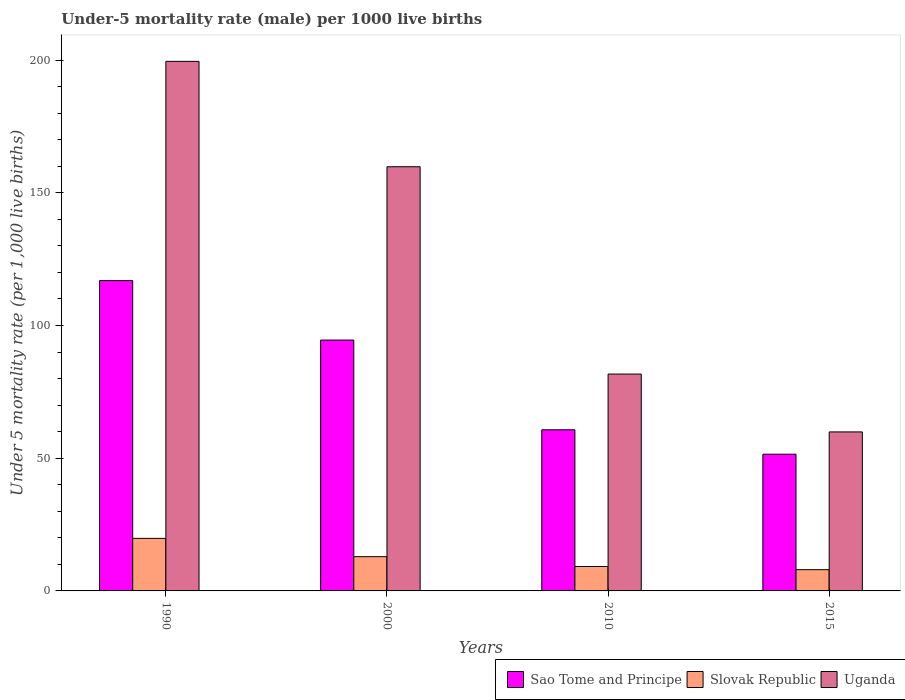How many different coloured bars are there?
Keep it short and to the point. 3. How many groups of bars are there?
Offer a very short reply. 4. Are the number of bars on each tick of the X-axis equal?
Your response must be concise. Yes. How many bars are there on the 1st tick from the right?
Provide a short and direct response. 3. What is the label of the 4th group of bars from the left?
Offer a very short reply. 2015. In how many cases, is the number of bars for a given year not equal to the number of legend labels?
Your answer should be compact. 0. Across all years, what is the maximum under-five mortality rate in Slovak Republic?
Your answer should be compact. 19.8. Across all years, what is the minimum under-five mortality rate in Sao Tome and Principe?
Your response must be concise. 51.5. In which year was the under-five mortality rate in Slovak Republic maximum?
Ensure brevity in your answer.  1990. In which year was the under-five mortality rate in Uganda minimum?
Offer a very short reply. 2015. What is the total under-five mortality rate in Uganda in the graph?
Provide a succinct answer. 500.9. What is the difference between the under-five mortality rate in Sao Tome and Principe in 2010 and that in 2015?
Your answer should be very brief. 9.2. What is the difference between the under-five mortality rate in Slovak Republic in 2010 and the under-five mortality rate in Uganda in 2015?
Make the answer very short. -50.7. What is the average under-five mortality rate in Slovak Republic per year?
Offer a terse response. 12.48. In the year 1990, what is the difference between the under-five mortality rate in Sao Tome and Principe and under-five mortality rate in Uganda?
Your response must be concise. -82.6. What is the ratio of the under-five mortality rate in Slovak Republic in 1990 to that in 2000?
Your answer should be compact. 1.53. What is the difference between the highest and the second highest under-five mortality rate in Sao Tome and Principe?
Give a very brief answer. 22.4. What is the difference between the highest and the lowest under-five mortality rate in Slovak Republic?
Your answer should be compact. 11.8. In how many years, is the under-five mortality rate in Slovak Republic greater than the average under-five mortality rate in Slovak Republic taken over all years?
Make the answer very short. 2. Is the sum of the under-five mortality rate in Uganda in 1990 and 2015 greater than the maximum under-five mortality rate in Sao Tome and Principe across all years?
Keep it short and to the point. Yes. What does the 1st bar from the left in 2010 represents?
Your response must be concise. Sao Tome and Principe. What does the 2nd bar from the right in 2015 represents?
Offer a very short reply. Slovak Republic. Is it the case that in every year, the sum of the under-five mortality rate in Uganda and under-five mortality rate in Sao Tome and Principe is greater than the under-five mortality rate in Slovak Republic?
Your response must be concise. Yes. How many bars are there?
Your answer should be compact. 12. Are all the bars in the graph horizontal?
Offer a very short reply. No. How many years are there in the graph?
Your response must be concise. 4. Does the graph contain grids?
Offer a terse response. No. Where does the legend appear in the graph?
Offer a very short reply. Bottom right. How are the legend labels stacked?
Provide a short and direct response. Horizontal. What is the title of the graph?
Give a very brief answer. Under-5 mortality rate (male) per 1000 live births. What is the label or title of the X-axis?
Offer a terse response. Years. What is the label or title of the Y-axis?
Make the answer very short. Under 5 mortality rate (per 1,0 live births). What is the Under 5 mortality rate (per 1,000 live births) in Sao Tome and Principe in 1990?
Keep it short and to the point. 116.9. What is the Under 5 mortality rate (per 1,000 live births) in Slovak Republic in 1990?
Keep it short and to the point. 19.8. What is the Under 5 mortality rate (per 1,000 live births) of Uganda in 1990?
Offer a very short reply. 199.5. What is the Under 5 mortality rate (per 1,000 live births) in Sao Tome and Principe in 2000?
Your answer should be compact. 94.5. What is the Under 5 mortality rate (per 1,000 live births) in Uganda in 2000?
Offer a very short reply. 159.8. What is the Under 5 mortality rate (per 1,000 live births) of Sao Tome and Principe in 2010?
Offer a very short reply. 60.7. What is the Under 5 mortality rate (per 1,000 live births) of Slovak Republic in 2010?
Make the answer very short. 9.2. What is the Under 5 mortality rate (per 1,000 live births) in Uganda in 2010?
Offer a terse response. 81.7. What is the Under 5 mortality rate (per 1,000 live births) in Sao Tome and Principe in 2015?
Make the answer very short. 51.5. What is the Under 5 mortality rate (per 1,000 live births) in Slovak Republic in 2015?
Ensure brevity in your answer.  8. What is the Under 5 mortality rate (per 1,000 live births) of Uganda in 2015?
Offer a very short reply. 59.9. Across all years, what is the maximum Under 5 mortality rate (per 1,000 live births) of Sao Tome and Principe?
Give a very brief answer. 116.9. Across all years, what is the maximum Under 5 mortality rate (per 1,000 live births) of Slovak Republic?
Give a very brief answer. 19.8. Across all years, what is the maximum Under 5 mortality rate (per 1,000 live births) in Uganda?
Keep it short and to the point. 199.5. Across all years, what is the minimum Under 5 mortality rate (per 1,000 live births) in Sao Tome and Principe?
Your response must be concise. 51.5. Across all years, what is the minimum Under 5 mortality rate (per 1,000 live births) in Slovak Republic?
Offer a terse response. 8. Across all years, what is the minimum Under 5 mortality rate (per 1,000 live births) of Uganda?
Offer a very short reply. 59.9. What is the total Under 5 mortality rate (per 1,000 live births) of Sao Tome and Principe in the graph?
Keep it short and to the point. 323.6. What is the total Under 5 mortality rate (per 1,000 live births) in Slovak Republic in the graph?
Keep it short and to the point. 49.9. What is the total Under 5 mortality rate (per 1,000 live births) of Uganda in the graph?
Your answer should be very brief. 500.9. What is the difference between the Under 5 mortality rate (per 1,000 live births) of Sao Tome and Principe in 1990 and that in 2000?
Your answer should be very brief. 22.4. What is the difference between the Under 5 mortality rate (per 1,000 live births) in Uganda in 1990 and that in 2000?
Keep it short and to the point. 39.7. What is the difference between the Under 5 mortality rate (per 1,000 live births) in Sao Tome and Principe in 1990 and that in 2010?
Give a very brief answer. 56.2. What is the difference between the Under 5 mortality rate (per 1,000 live births) in Slovak Republic in 1990 and that in 2010?
Give a very brief answer. 10.6. What is the difference between the Under 5 mortality rate (per 1,000 live births) of Uganda in 1990 and that in 2010?
Offer a very short reply. 117.8. What is the difference between the Under 5 mortality rate (per 1,000 live births) of Sao Tome and Principe in 1990 and that in 2015?
Keep it short and to the point. 65.4. What is the difference between the Under 5 mortality rate (per 1,000 live births) of Uganda in 1990 and that in 2015?
Give a very brief answer. 139.6. What is the difference between the Under 5 mortality rate (per 1,000 live births) of Sao Tome and Principe in 2000 and that in 2010?
Ensure brevity in your answer.  33.8. What is the difference between the Under 5 mortality rate (per 1,000 live births) of Slovak Republic in 2000 and that in 2010?
Offer a very short reply. 3.7. What is the difference between the Under 5 mortality rate (per 1,000 live births) in Uganda in 2000 and that in 2010?
Offer a very short reply. 78.1. What is the difference between the Under 5 mortality rate (per 1,000 live births) of Slovak Republic in 2000 and that in 2015?
Your response must be concise. 4.9. What is the difference between the Under 5 mortality rate (per 1,000 live births) of Uganda in 2000 and that in 2015?
Offer a very short reply. 99.9. What is the difference between the Under 5 mortality rate (per 1,000 live births) in Sao Tome and Principe in 2010 and that in 2015?
Offer a very short reply. 9.2. What is the difference between the Under 5 mortality rate (per 1,000 live births) of Slovak Republic in 2010 and that in 2015?
Make the answer very short. 1.2. What is the difference between the Under 5 mortality rate (per 1,000 live births) of Uganda in 2010 and that in 2015?
Your answer should be very brief. 21.8. What is the difference between the Under 5 mortality rate (per 1,000 live births) of Sao Tome and Principe in 1990 and the Under 5 mortality rate (per 1,000 live births) of Slovak Republic in 2000?
Provide a short and direct response. 104. What is the difference between the Under 5 mortality rate (per 1,000 live births) in Sao Tome and Principe in 1990 and the Under 5 mortality rate (per 1,000 live births) in Uganda in 2000?
Give a very brief answer. -42.9. What is the difference between the Under 5 mortality rate (per 1,000 live births) in Slovak Republic in 1990 and the Under 5 mortality rate (per 1,000 live births) in Uganda in 2000?
Ensure brevity in your answer.  -140. What is the difference between the Under 5 mortality rate (per 1,000 live births) of Sao Tome and Principe in 1990 and the Under 5 mortality rate (per 1,000 live births) of Slovak Republic in 2010?
Give a very brief answer. 107.7. What is the difference between the Under 5 mortality rate (per 1,000 live births) of Sao Tome and Principe in 1990 and the Under 5 mortality rate (per 1,000 live births) of Uganda in 2010?
Offer a very short reply. 35.2. What is the difference between the Under 5 mortality rate (per 1,000 live births) of Slovak Republic in 1990 and the Under 5 mortality rate (per 1,000 live births) of Uganda in 2010?
Ensure brevity in your answer.  -61.9. What is the difference between the Under 5 mortality rate (per 1,000 live births) of Sao Tome and Principe in 1990 and the Under 5 mortality rate (per 1,000 live births) of Slovak Republic in 2015?
Make the answer very short. 108.9. What is the difference between the Under 5 mortality rate (per 1,000 live births) of Sao Tome and Principe in 1990 and the Under 5 mortality rate (per 1,000 live births) of Uganda in 2015?
Make the answer very short. 57. What is the difference between the Under 5 mortality rate (per 1,000 live births) in Slovak Republic in 1990 and the Under 5 mortality rate (per 1,000 live births) in Uganda in 2015?
Offer a very short reply. -40.1. What is the difference between the Under 5 mortality rate (per 1,000 live births) of Sao Tome and Principe in 2000 and the Under 5 mortality rate (per 1,000 live births) of Slovak Republic in 2010?
Make the answer very short. 85.3. What is the difference between the Under 5 mortality rate (per 1,000 live births) in Slovak Republic in 2000 and the Under 5 mortality rate (per 1,000 live births) in Uganda in 2010?
Your answer should be compact. -68.8. What is the difference between the Under 5 mortality rate (per 1,000 live births) in Sao Tome and Principe in 2000 and the Under 5 mortality rate (per 1,000 live births) in Slovak Republic in 2015?
Your answer should be compact. 86.5. What is the difference between the Under 5 mortality rate (per 1,000 live births) of Sao Tome and Principe in 2000 and the Under 5 mortality rate (per 1,000 live births) of Uganda in 2015?
Offer a terse response. 34.6. What is the difference between the Under 5 mortality rate (per 1,000 live births) in Slovak Republic in 2000 and the Under 5 mortality rate (per 1,000 live births) in Uganda in 2015?
Make the answer very short. -47. What is the difference between the Under 5 mortality rate (per 1,000 live births) in Sao Tome and Principe in 2010 and the Under 5 mortality rate (per 1,000 live births) in Slovak Republic in 2015?
Give a very brief answer. 52.7. What is the difference between the Under 5 mortality rate (per 1,000 live births) in Sao Tome and Principe in 2010 and the Under 5 mortality rate (per 1,000 live births) in Uganda in 2015?
Provide a short and direct response. 0.8. What is the difference between the Under 5 mortality rate (per 1,000 live births) of Slovak Republic in 2010 and the Under 5 mortality rate (per 1,000 live births) of Uganda in 2015?
Keep it short and to the point. -50.7. What is the average Under 5 mortality rate (per 1,000 live births) of Sao Tome and Principe per year?
Offer a terse response. 80.9. What is the average Under 5 mortality rate (per 1,000 live births) in Slovak Republic per year?
Keep it short and to the point. 12.47. What is the average Under 5 mortality rate (per 1,000 live births) in Uganda per year?
Your response must be concise. 125.22. In the year 1990, what is the difference between the Under 5 mortality rate (per 1,000 live births) of Sao Tome and Principe and Under 5 mortality rate (per 1,000 live births) of Slovak Republic?
Make the answer very short. 97.1. In the year 1990, what is the difference between the Under 5 mortality rate (per 1,000 live births) of Sao Tome and Principe and Under 5 mortality rate (per 1,000 live births) of Uganda?
Ensure brevity in your answer.  -82.6. In the year 1990, what is the difference between the Under 5 mortality rate (per 1,000 live births) in Slovak Republic and Under 5 mortality rate (per 1,000 live births) in Uganda?
Offer a terse response. -179.7. In the year 2000, what is the difference between the Under 5 mortality rate (per 1,000 live births) in Sao Tome and Principe and Under 5 mortality rate (per 1,000 live births) in Slovak Republic?
Your response must be concise. 81.6. In the year 2000, what is the difference between the Under 5 mortality rate (per 1,000 live births) of Sao Tome and Principe and Under 5 mortality rate (per 1,000 live births) of Uganda?
Your answer should be compact. -65.3. In the year 2000, what is the difference between the Under 5 mortality rate (per 1,000 live births) of Slovak Republic and Under 5 mortality rate (per 1,000 live births) of Uganda?
Offer a very short reply. -146.9. In the year 2010, what is the difference between the Under 5 mortality rate (per 1,000 live births) in Sao Tome and Principe and Under 5 mortality rate (per 1,000 live births) in Slovak Republic?
Keep it short and to the point. 51.5. In the year 2010, what is the difference between the Under 5 mortality rate (per 1,000 live births) of Sao Tome and Principe and Under 5 mortality rate (per 1,000 live births) of Uganda?
Your answer should be very brief. -21. In the year 2010, what is the difference between the Under 5 mortality rate (per 1,000 live births) in Slovak Republic and Under 5 mortality rate (per 1,000 live births) in Uganda?
Offer a very short reply. -72.5. In the year 2015, what is the difference between the Under 5 mortality rate (per 1,000 live births) of Sao Tome and Principe and Under 5 mortality rate (per 1,000 live births) of Slovak Republic?
Keep it short and to the point. 43.5. In the year 2015, what is the difference between the Under 5 mortality rate (per 1,000 live births) of Slovak Republic and Under 5 mortality rate (per 1,000 live births) of Uganda?
Ensure brevity in your answer.  -51.9. What is the ratio of the Under 5 mortality rate (per 1,000 live births) of Sao Tome and Principe in 1990 to that in 2000?
Offer a very short reply. 1.24. What is the ratio of the Under 5 mortality rate (per 1,000 live births) in Slovak Republic in 1990 to that in 2000?
Offer a very short reply. 1.53. What is the ratio of the Under 5 mortality rate (per 1,000 live births) in Uganda in 1990 to that in 2000?
Provide a short and direct response. 1.25. What is the ratio of the Under 5 mortality rate (per 1,000 live births) in Sao Tome and Principe in 1990 to that in 2010?
Ensure brevity in your answer.  1.93. What is the ratio of the Under 5 mortality rate (per 1,000 live births) in Slovak Republic in 1990 to that in 2010?
Your answer should be very brief. 2.15. What is the ratio of the Under 5 mortality rate (per 1,000 live births) of Uganda in 1990 to that in 2010?
Provide a short and direct response. 2.44. What is the ratio of the Under 5 mortality rate (per 1,000 live births) in Sao Tome and Principe in 1990 to that in 2015?
Your answer should be very brief. 2.27. What is the ratio of the Under 5 mortality rate (per 1,000 live births) in Slovak Republic in 1990 to that in 2015?
Provide a succinct answer. 2.48. What is the ratio of the Under 5 mortality rate (per 1,000 live births) of Uganda in 1990 to that in 2015?
Ensure brevity in your answer.  3.33. What is the ratio of the Under 5 mortality rate (per 1,000 live births) of Sao Tome and Principe in 2000 to that in 2010?
Make the answer very short. 1.56. What is the ratio of the Under 5 mortality rate (per 1,000 live births) in Slovak Republic in 2000 to that in 2010?
Keep it short and to the point. 1.4. What is the ratio of the Under 5 mortality rate (per 1,000 live births) in Uganda in 2000 to that in 2010?
Give a very brief answer. 1.96. What is the ratio of the Under 5 mortality rate (per 1,000 live births) of Sao Tome and Principe in 2000 to that in 2015?
Give a very brief answer. 1.83. What is the ratio of the Under 5 mortality rate (per 1,000 live births) of Slovak Republic in 2000 to that in 2015?
Your response must be concise. 1.61. What is the ratio of the Under 5 mortality rate (per 1,000 live births) in Uganda in 2000 to that in 2015?
Provide a succinct answer. 2.67. What is the ratio of the Under 5 mortality rate (per 1,000 live births) in Sao Tome and Principe in 2010 to that in 2015?
Your answer should be compact. 1.18. What is the ratio of the Under 5 mortality rate (per 1,000 live births) in Slovak Republic in 2010 to that in 2015?
Make the answer very short. 1.15. What is the ratio of the Under 5 mortality rate (per 1,000 live births) of Uganda in 2010 to that in 2015?
Your response must be concise. 1.36. What is the difference between the highest and the second highest Under 5 mortality rate (per 1,000 live births) of Sao Tome and Principe?
Provide a short and direct response. 22.4. What is the difference between the highest and the second highest Under 5 mortality rate (per 1,000 live births) in Slovak Republic?
Make the answer very short. 6.9. What is the difference between the highest and the second highest Under 5 mortality rate (per 1,000 live births) of Uganda?
Provide a short and direct response. 39.7. What is the difference between the highest and the lowest Under 5 mortality rate (per 1,000 live births) in Sao Tome and Principe?
Provide a succinct answer. 65.4. What is the difference between the highest and the lowest Under 5 mortality rate (per 1,000 live births) of Uganda?
Provide a short and direct response. 139.6. 